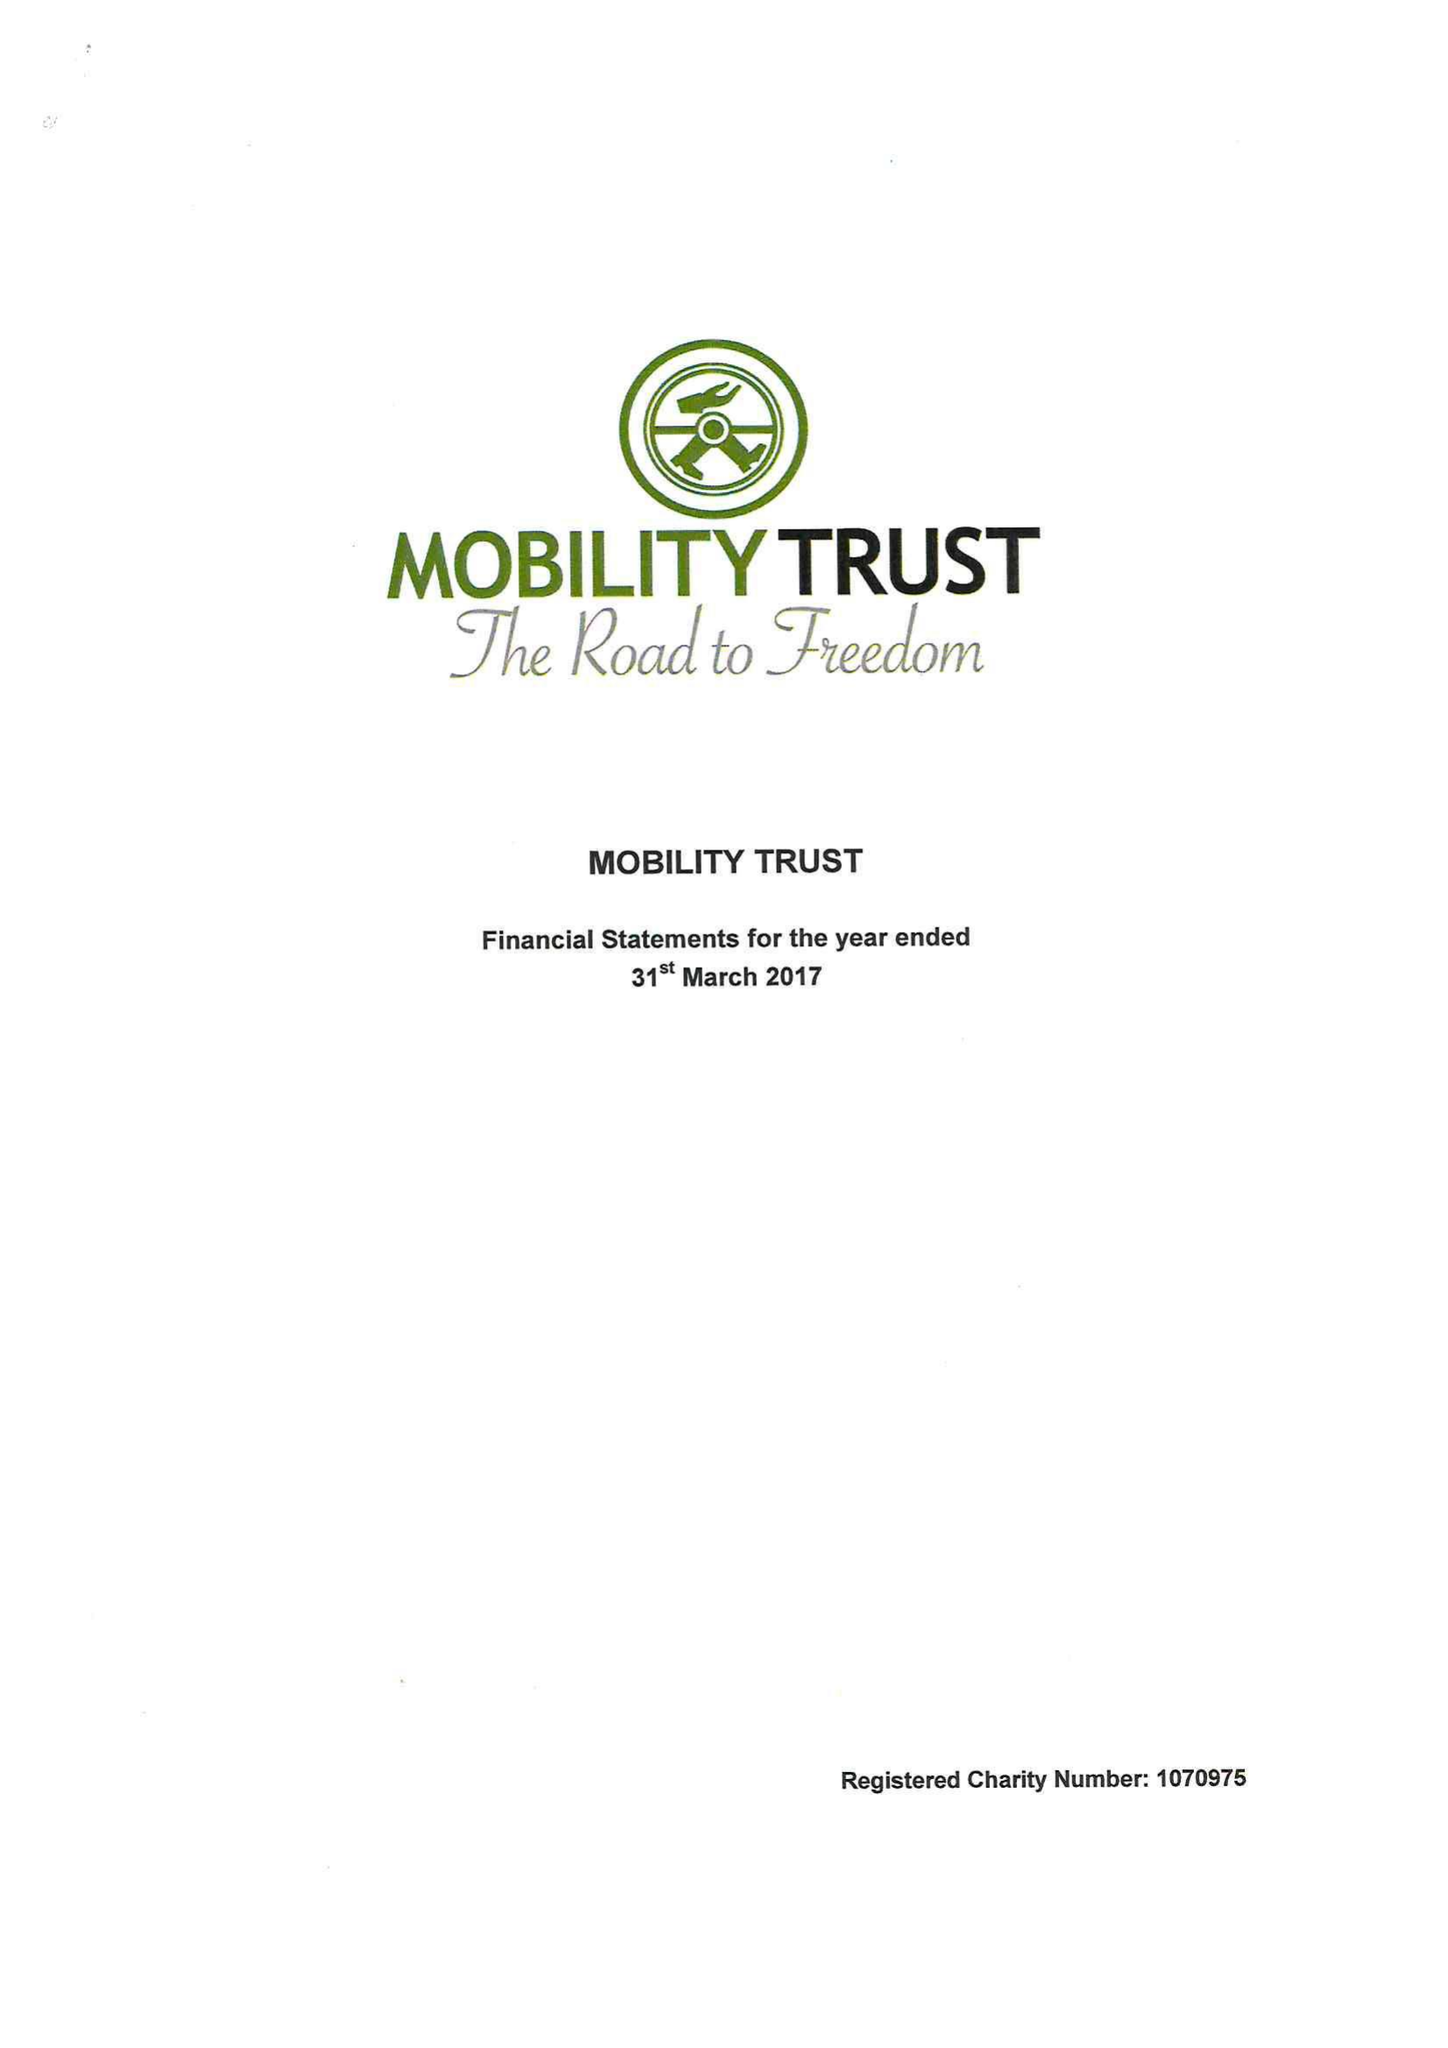What is the value for the address__street_line?
Answer the question using a single word or phrase. 19 READING ROAD 